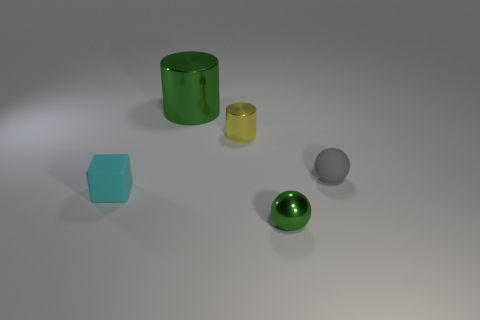How many objects are tiny rubber objects that are to the right of the green shiny cylinder or tiny cyan cubes?
Provide a succinct answer. 2. Are there the same number of small shiny balls that are to the right of the tiny green metal thing and big green shiny things that are left of the small rubber ball?
Your answer should be very brief. No. The tiny object that is to the left of the cylinder in front of the green object behind the small cyan object is made of what material?
Provide a short and direct response. Rubber. What size is the object that is both on the right side of the yellow cylinder and behind the green metallic sphere?
Keep it short and to the point. Small. Is the small gray object the same shape as the small yellow metal thing?
Provide a succinct answer. No. There is a small gray thing that is the same material as the cube; what is its shape?
Your answer should be compact. Sphere. What number of big objects are either yellow cylinders or yellow rubber objects?
Keep it short and to the point. 0. There is a matte thing that is to the left of the tiny green thing; are there any small green shiny balls behind it?
Provide a succinct answer. No. Is there a purple metal cube?
Make the answer very short. No. There is a object on the right side of the metal thing that is in front of the yellow shiny thing; what color is it?
Provide a short and direct response. Gray. 